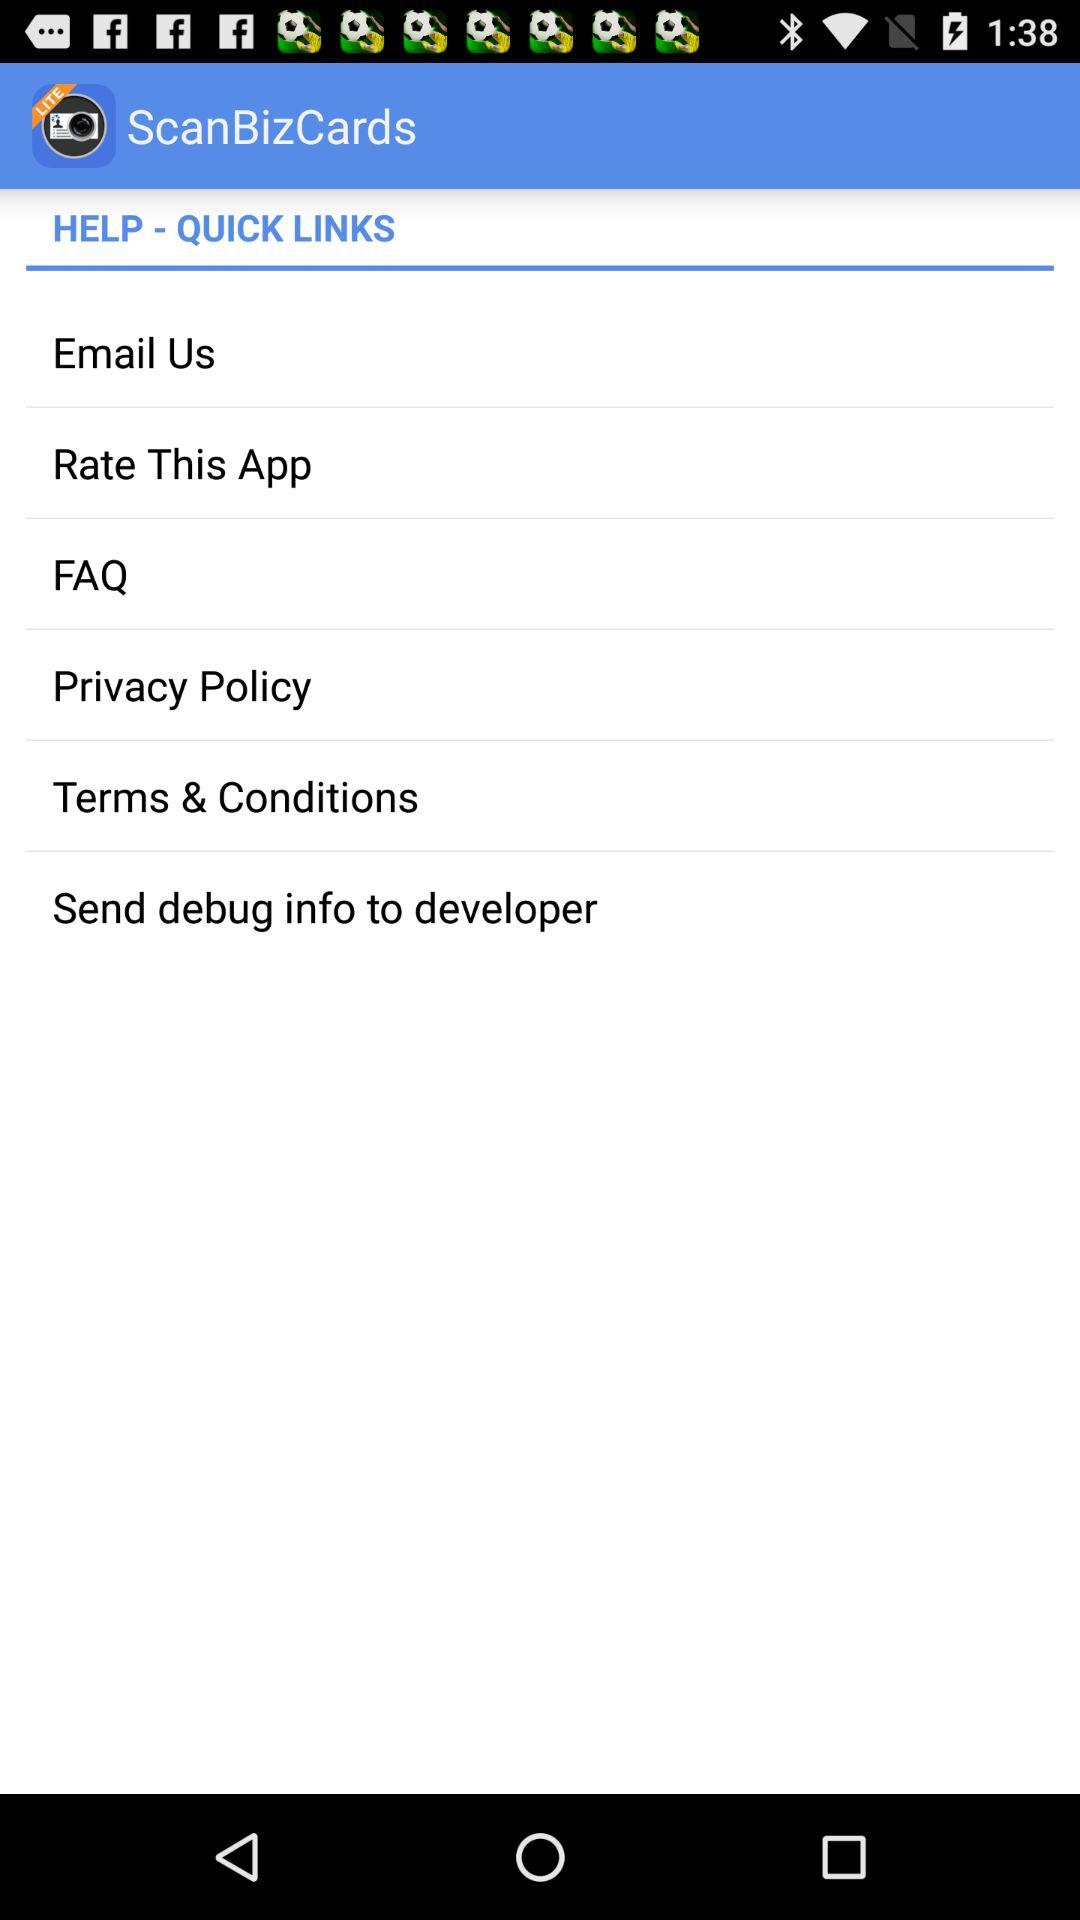What is the application name? The application name is "ScanBizCards". 